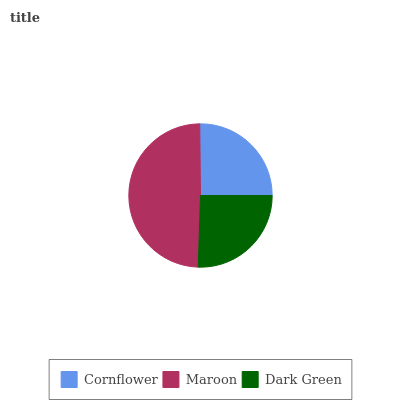Is Cornflower the minimum?
Answer yes or no. Yes. Is Maroon the maximum?
Answer yes or no. Yes. Is Dark Green the minimum?
Answer yes or no. No. Is Dark Green the maximum?
Answer yes or no. No. Is Maroon greater than Dark Green?
Answer yes or no. Yes. Is Dark Green less than Maroon?
Answer yes or no. Yes. Is Dark Green greater than Maroon?
Answer yes or no. No. Is Maroon less than Dark Green?
Answer yes or no. No. Is Dark Green the high median?
Answer yes or no. Yes. Is Dark Green the low median?
Answer yes or no. Yes. Is Cornflower the high median?
Answer yes or no. No. Is Maroon the low median?
Answer yes or no. No. 